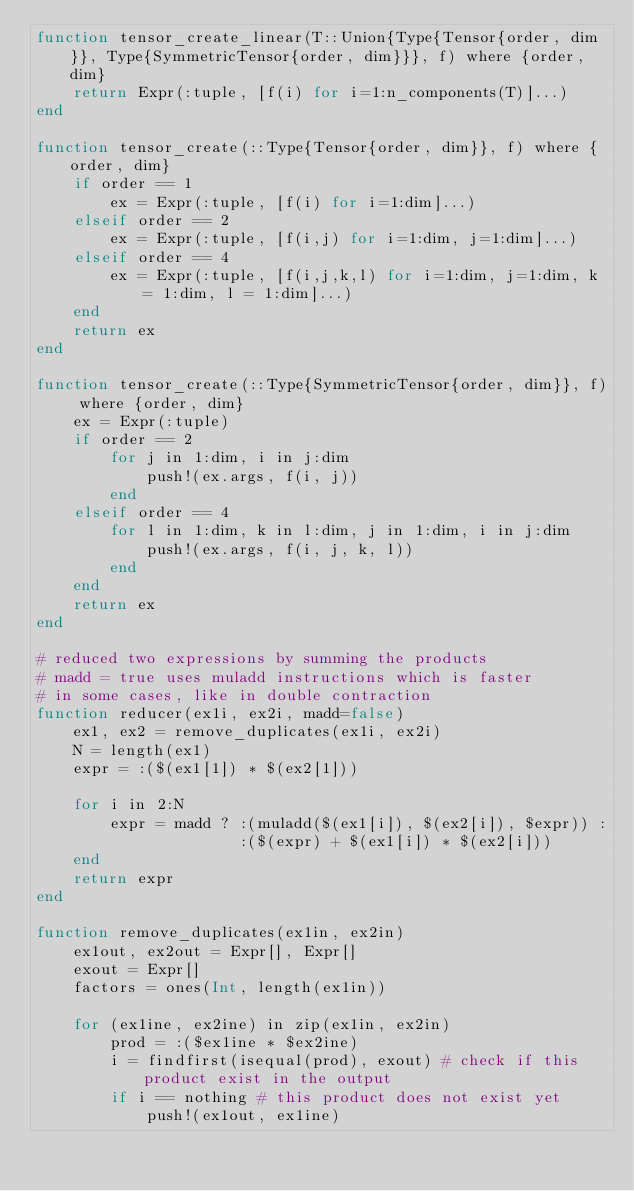Convert code to text. <code><loc_0><loc_0><loc_500><loc_500><_Julia_>function tensor_create_linear(T::Union{Type{Tensor{order, dim}}, Type{SymmetricTensor{order, dim}}}, f) where {order, dim}
    return Expr(:tuple, [f(i) for i=1:n_components(T)]...)
end

function tensor_create(::Type{Tensor{order, dim}}, f) where {order, dim}
    if order == 1
        ex = Expr(:tuple, [f(i) for i=1:dim]...)
    elseif order == 2
        ex = Expr(:tuple, [f(i,j) for i=1:dim, j=1:dim]...)
    elseif order == 4
        ex = Expr(:tuple, [f(i,j,k,l) for i=1:dim, j=1:dim, k = 1:dim, l = 1:dim]...)
    end
    return ex
end

function tensor_create(::Type{SymmetricTensor{order, dim}}, f) where {order, dim}
    ex = Expr(:tuple)
    if order == 2
        for j in 1:dim, i in j:dim
            push!(ex.args, f(i, j))
        end
    elseif order == 4
        for l in 1:dim, k in l:dim, j in 1:dim, i in j:dim
            push!(ex.args, f(i, j, k, l))
        end
    end
    return ex
end

# reduced two expressions by summing the products
# madd = true uses muladd instructions which is faster
# in some cases, like in double contraction
function reducer(ex1i, ex2i, madd=false)
    ex1, ex2 = remove_duplicates(ex1i, ex2i)
    N = length(ex1)
    expr = :($(ex1[1]) * $(ex2[1]))

    for i in 2:N
        expr = madd ? :(muladd($(ex1[i]), $(ex2[i]), $expr)) :
                      :($(expr) + $(ex1[i]) * $(ex2[i]))
    end
    return expr
end

function remove_duplicates(ex1in, ex2in)
    ex1out, ex2out = Expr[], Expr[]
    exout = Expr[]
    factors = ones(Int, length(ex1in))

    for (ex1ine, ex2ine) in zip(ex1in, ex2in)
        prod = :($ex1ine * $ex2ine)
        i = findfirst(isequal(prod), exout) # check if this product exist in the output
        if i == nothing # this product does not exist yet
            push!(ex1out, ex1ine)</code> 